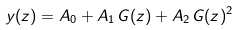<formula> <loc_0><loc_0><loc_500><loc_500>y ( z ) = A _ { 0 } + A _ { 1 } \, G ( z ) + A _ { 2 } \, G ( z ) ^ { 2 }</formula> 